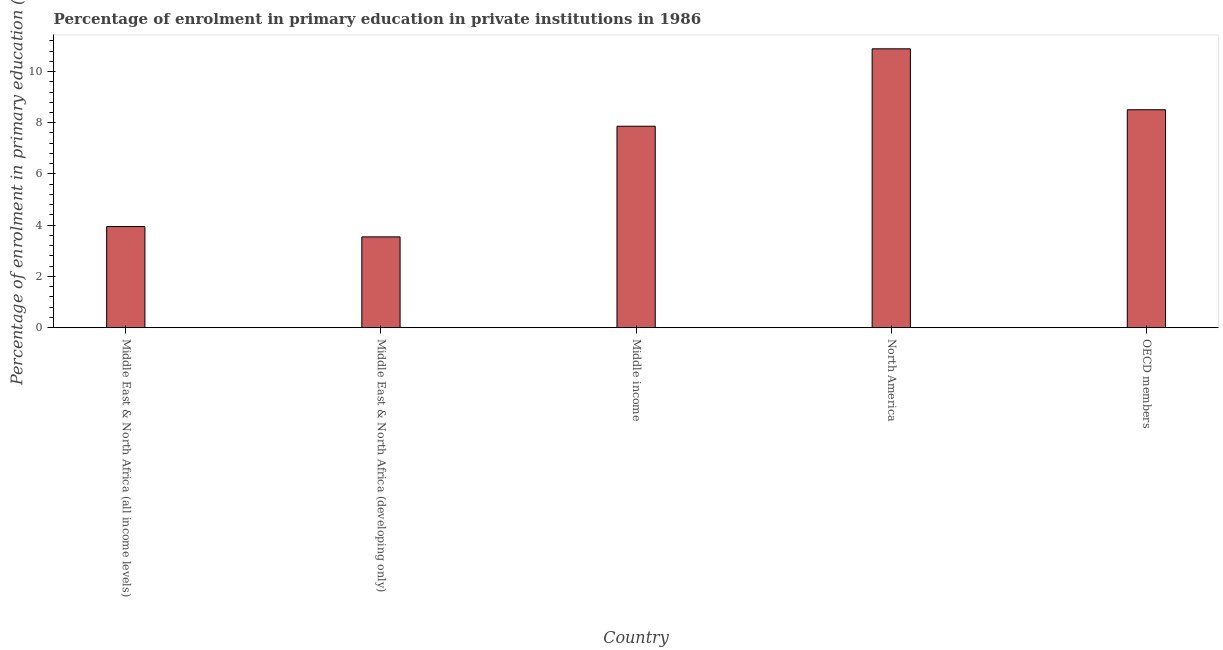Does the graph contain grids?
Offer a terse response. No. What is the title of the graph?
Offer a terse response. Percentage of enrolment in primary education in private institutions in 1986. What is the label or title of the Y-axis?
Provide a short and direct response. Percentage of enrolment in primary education (%). What is the enrolment percentage in primary education in Middle East & North Africa (developing only)?
Your response must be concise. 3.54. Across all countries, what is the maximum enrolment percentage in primary education?
Make the answer very short. 10.89. Across all countries, what is the minimum enrolment percentage in primary education?
Make the answer very short. 3.54. In which country was the enrolment percentage in primary education minimum?
Keep it short and to the point. Middle East & North Africa (developing only). What is the sum of the enrolment percentage in primary education?
Your answer should be compact. 34.75. What is the difference between the enrolment percentage in primary education in Middle income and OECD members?
Make the answer very short. -0.64. What is the average enrolment percentage in primary education per country?
Offer a very short reply. 6.95. What is the median enrolment percentage in primary education?
Offer a very short reply. 7.86. In how many countries, is the enrolment percentage in primary education greater than 8.4 %?
Make the answer very short. 2. What is the ratio of the enrolment percentage in primary education in Middle income to that in OECD members?
Make the answer very short. 0.92. Is the enrolment percentage in primary education in Middle East & North Africa (all income levels) less than that in Middle East & North Africa (developing only)?
Your answer should be compact. No. Is the difference between the enrolment percentage in primary education in Middle East & North Africa (all income levels) and Middle East & North Africa (developing only) greater than the difference between any two countries?
Your answer should be compact. No. What is the difference between the highest and the second highest enrolment percentage in primary education?
Make the answer very short. 2.38. What is the difference between the highest and the lowest enrolment percentage in primary education?
Keep it short and to the point. 7.34. In how many countries, is the enrolment percentage in primary education greater than the average enrolment percentage in primary education taken over all countries?
Your answer should be compact. 3. How many bars are there?
Offer a very short reply. 5. How many countries are there in the graph?
Ensure brevity in your answer.  5. What is the Percentage of enrolment in primary education (%) in Middle East & North Africa (all income levels)?
Provide a succinct answer. 3.95. What is the Percentage of enrolment in primary education (%) in Middle East & North Africa (developing only)?
Offer a very short reply. 3.54. What is the Percentage of enrolment in primary education (%) in Middle income?
Provide a succinct answer. 7.86. What is the Percentage of enrolment in primary education (%) in North America?
Offer a terse response. 10.89. What is the Percentage of enrolment in primary education (%) in OECD members?
Give a very brief answer. 8.51. What is the difference between the Percentage of enrolment in primary education (%) in Middle East & North Africa (all income levels) and Middle East & North Africa (developing only)?
Your response must be concise. 0.4. What is the difference between the Percentage of enrolment in primary education (%) in Middle East & North Africa (all income levels) and Middle income?
Offer a very short reply. -3.92. What is the difference between the Percentage of enrolment in primary education (%) in Middle East & North Africa (all income levels) and North America?
Your answer should be compact. -6.94. What is the difference between the Percentage of enrolment in primary education (%) in Middle East & North Africa (all income levels) and OECD members?
Offer a very short reply. -4.56. What is the difference between the Percentage of enrolment in primary education (%) in Middle East & North Africa (developing only) and Middle income?
Provide a short and direct response. -4.32. What is the difference between the Percentage of enrolment in primary education (%) in Middle East & North Africa (developing only) and North America?
Provide a short and direct response. -7.34. What is the difference between the Percentage of enrolment in primary education (%) in Middle East & North Africa (developing only) and OECD members?
Provide a succinct answer. -4.96. What is the difference between the Percentage of enrolment in primary education (%) in Middle income and North America?
Keep it short and to the point. -3.02. What is the difference between the Percentage of enrolment in primary education (%) in Middle income and OECD members?
Make the answer very short. -0.64. What is the difference between the Percentage of enrolment in primary education (%) in North America and OECD members?
Ensure brevity in your answer.  2.38. What is the ratio of the Percentage of enrolment in primary education (%) in Middle East & North Africa (all income levels) to that in Middle East & North Africa (developing only)?
Offer a terse response. 1.11. What is the ratio of the Percentage of enrolment in primary education (%) in Middle East & North Africa (all income levels) to that in Middle income?
Provide a short and direct response. 0.5. What is the ratio of the Percentage of enrolment in primary education (%) in Middle East & North Africa (all income levels) to that in North America?
Your response must be concise. 0.36. What is the ratio of the Percentage of enrolment in primary education (%) in Middle East & North Africa (all income levels) to that in OECD members?
Your answer should be compact. 0.46. What is the ratio of the Percentage of enrolment in primary education (%) in Middle East & North Africa (developing only) to that in Middle income?
Offer a terse response. 0.45. What is the ratio of the Percentage of enrolment in primary education (%) in Middle East & North Africa (developing only) to that in North America?
Your response must be concise. 0.33. What is the ratio of the Percentage of enrolment in primary education (%) in Middle East & North Africa (developing only) to that in OECD members?
Offer a very short reply. 0.42. What is the ratio of the Percentage of enrolment in primary education (%) in Middle income to that in North America?
Give a very brief answer. 0.72. What is the ratio of the Percentage of enrolment in primary education (%) in Middle income to that in OECD members?
Offer a terse response. 0.92. What is the ratio of the Percentage of enrolment in primary education (%) in North America to that in OECD members?
Your answer should be compact. 1.28. 